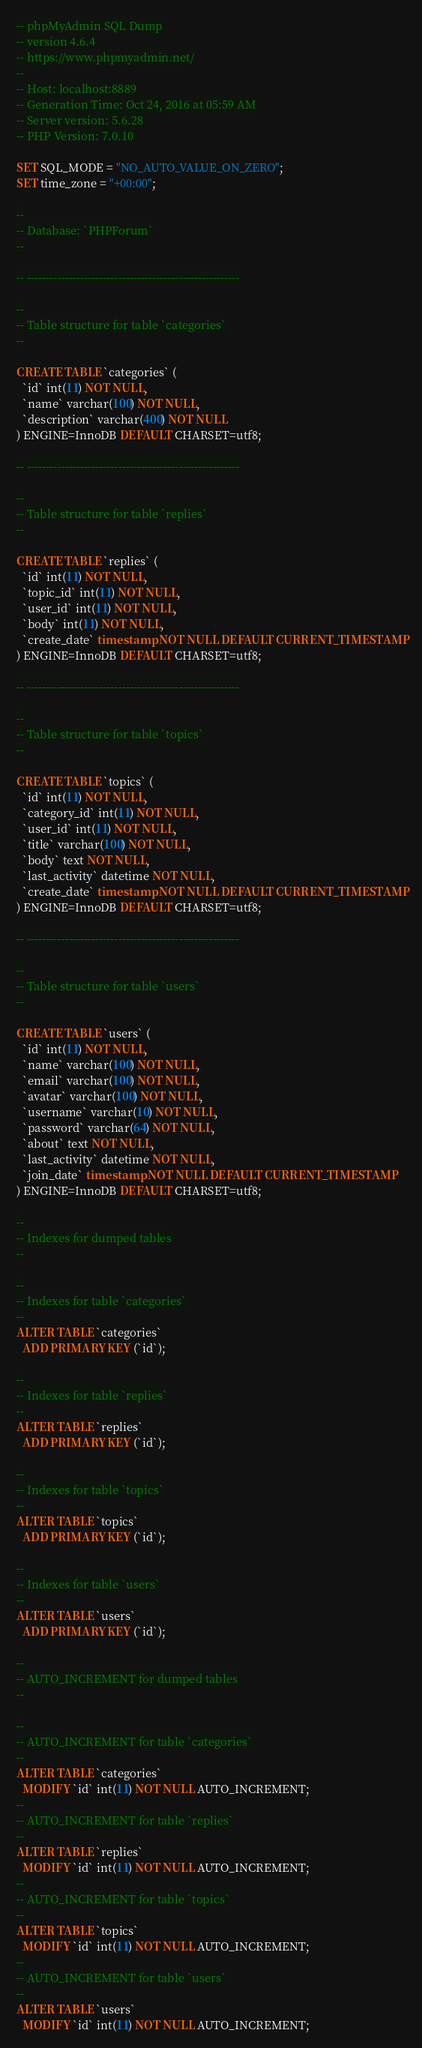<code> <loc_0><loc_0><loc_500><loc_500><_SQL_>-- phpMyAdmin SQL Dump
-- version 4.6.4
-- https://www.phpmyadmin.net/
--
-- Host: localhost:8889
-- Generation Time: Oct 24, 2016 at 05:59 AM
-- Server version: 5.6.28
-- PHP Version: 7.0.10

SET SQL_MODE = "NO_AUTO_VALUE_ON_ZERO";
SET time_zone = "+00:00";

--
-- Database: `PHPForum`
--

-- --------------------------------------------------------

--
-- Table structure for table `categories`
--

CREATE TABLE `categories` (
  `id` int(11) NOT NULL,
  `name` varchar(100) NOT NULL,
  `description` varchar(400) NOT NULL
) ENGINE=InnoDB DEFAULT CHARSET=utf8;

-- --------------------------------------------------------

--
-- Table structure for table `replies`
--

CREATE TABLE `replies` (
  `id` int(11) NOT NULL,
  `topic_id` int(11) NOT NULL,
  `user_id` int(11) NOT NULL,
  `body` int(11) NOT NULL,
  `create_date` timestamp NOT NULL DEFAULT CURRENT_TIMESTAMP
) ENGINE=InnoDB DEFAULT CHARSET=utf8;

-- --------------------------------------------------------

--
-- Table structure for table `topics`
--

CREATE TABLE `topics` (
  `id` int(11) NOT NULL,
  `category_id` int(11) NOT NULL,
  `user_id` int(11) NOT NULL,
  `title` varchar(100) NOT NULL,
  `body` text NOT NULL,
  `last_activity` datetime NOT NULL,
  `create_date` timestamp NOT NULL DEFAULT CURRENT_TIMESTAMP
) ENGINE=InnoDB DEFAULT CHARSET=utf8;

-- --------------------------------------------------------

--
-- Table structure for table `users`
--

CREATE TABLE `users` (
  `id` int(11) NOT NULL,
  `name` varchar(100) NOT NULL,
  `email` varchar(100) NOT NULL,
  `avatar` varchar(100) NOT NULL,
  `username` varchar(10) NOT NULL,
  `password` varchar(64) NOT NULL,
  `about` text NOT NULL,
  `last_activity` datetime NOT NULL,
  `join_date` timestamp NOT NULL DEFAULT CURRENT_TIMESTAMP
) ENGINE=InnoDB DEFAULT CHARSET=utf8;

--
-- Indexes for dumped tables
--

--
-- Indexes for table `categories`
--
ALTER TABLE `categories`
  ADD PRIMARY KEY (`id`);

--
-- Indexes for table `replies`
--
ALTER TABLE `replies`
  ADD PRIMARY KEY (`id`);

--
-- Indexes for table `topics`
--
ALTER TABLE `topics`
  ADD PRIMARY KEY (`id`);

--
-- Indexes for table `users`
--
ALTER TABLE `users`
  ADD PRIMARY KEY (`id`);

--
-- AUTO_INCREMENT for dumped tables
--

--
-- AUTO_INCREMENT for table `categories`
--
ALTER TABLE `categories`
  MODIFY `id` int(11) NOT NULL AUTO_INCREMENT;
--
-- AUTO_INCREMENT for table `replies`
--
ALTER TABLE `replies`
  MODIFY `id` int(11) NOT NULL AUTO_INCREMENT;
--
-- AUTO_INCREMENT for table `topics`
--
ALTER TABLE `topics`
  MODIFY `id` int(11) NOT NULL AUTO_INCREMENT;
--
-- AUTO_INCREMENT for table `users`
--
ALTER TABLE `users`
  MODIFY `id` int(11) NOT NULL AUTO_INCREMENT;
</code> 